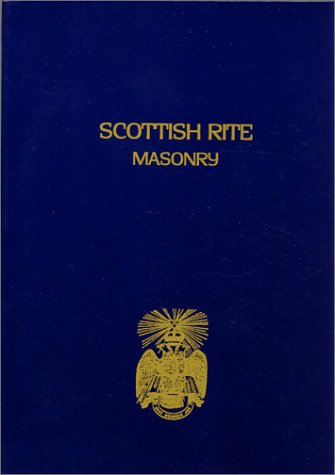Is this book related to Teen & Young Adult? No, this book is not targeted towards the Teen & Young Adult demographic. It primarily explores mature and intricate religious and spiritual themes specific to Masonic practices. 